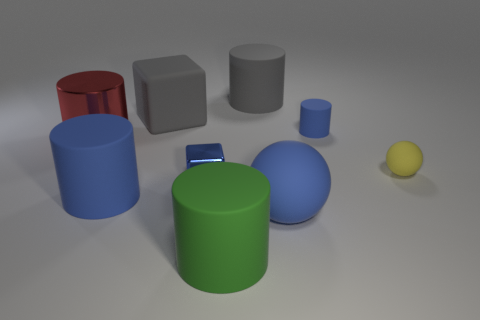Is the number of large rubber objects that are in front of the big gray rubber cylinder less than the number of large matte objects?
Make the answer very short. Yes. Are there any blue blocks that have the same material as the big red cylinder?
Offer a very short reply. Yes. Does the yellow matte object have the same size as the rubber cube behind the large matte ball?
Make the answer very short. No. Is there a rubber ball of the same color as the small cylinder?
Provide a short and direct response. Yes. Does the green thing have the same material as the tiny block?
Keep it short and to the point. No. There is a big red shiny thing; what number of tiny matte things are to the right of it?
Your answer should be very brief. 2. There is a small thing that is both to the left of the tiny sphere and in front of the red cylinder; what material is it?
Ensure brevity in your answer.  Metal. How many shiny cylinders are the same size as the blue ball?
Ensure brevity in your answer.  1. There is a cube in front of the blue matte object behind the big red cylinder; what color is it?
Your answer should be compact. Blue. Are there any brown matte objects?
Give a very brief answer. No. 